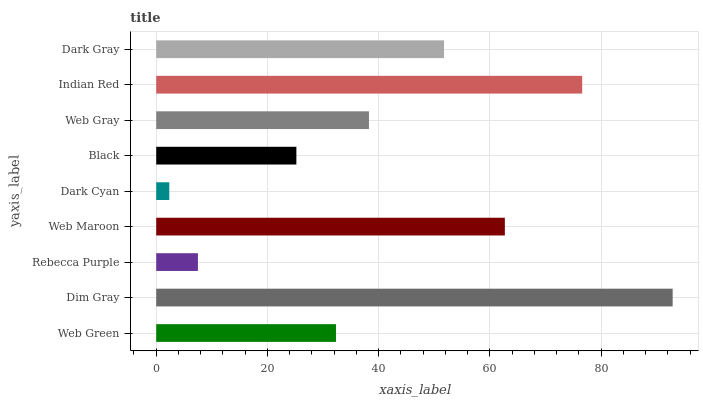Is Dark Cyan the minimum?
Answer yes or no. Yes. Is Dim Gray the maximum?
Answer yes or no. Yes. Is Rebecca Purple the minimum?
Answer yes or no. No. Is Rebecca Purple the maximum?
Answer yes or no. No. Is Dim Gray greater than Rebecca Purple?
Answer yes or no. Yes. Is Rebecca Purple less than Dim Gray?
Answer yes or no. Yes. Is Rebecca Purple greater than Dim Gray?
Answer yes or no. No. Is Dim Gray less than Rebecca Purple?
Answer yes or no. No. Is Web Gray the high median?
Answer yes or no. Yes. Is Web Gray the low median?
Answer yes or no. Yes. Is Web Green the high median?
Answer yes or no. No. Is Rebecca Purple the low median?
Answer yes or no. No. 